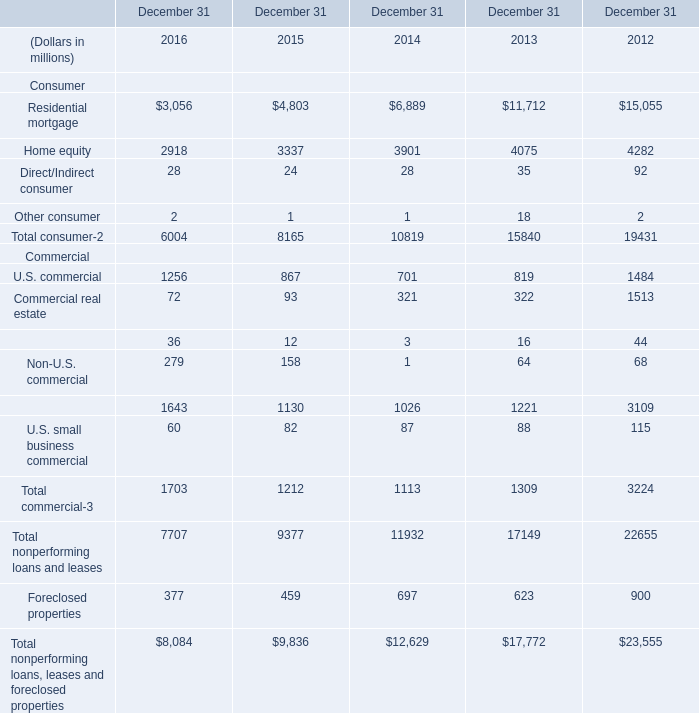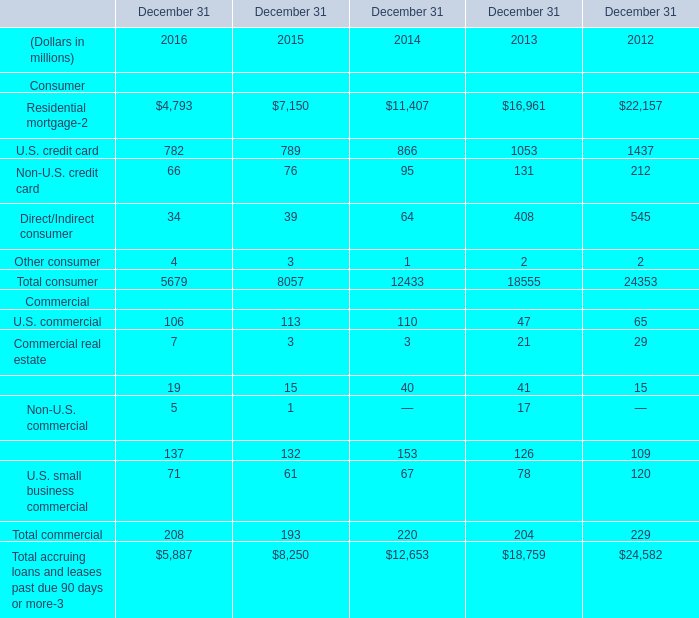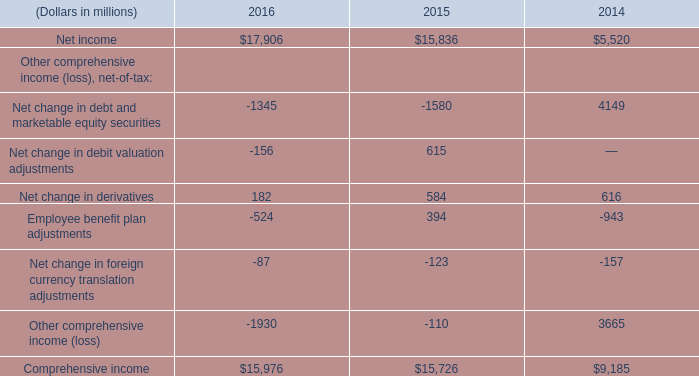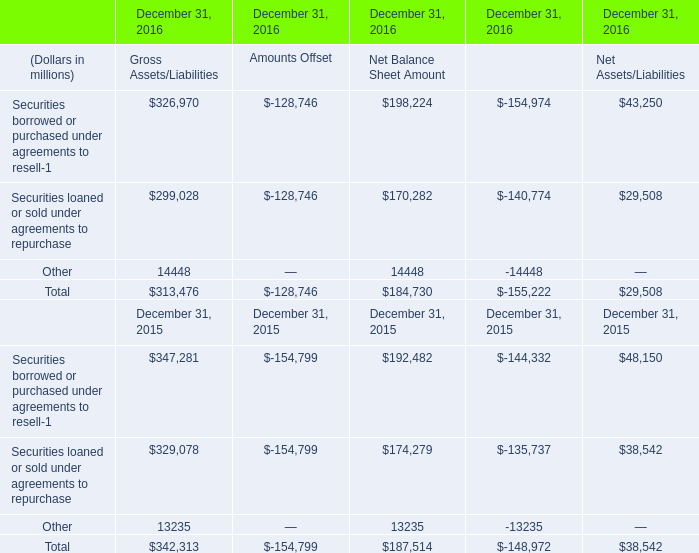In the year with lowest amount of Total consumer, what's the increasing rate of Total commercial ? (in %) 
Computations: ((208 - 193) / 193)
Answer: 0.07772. 